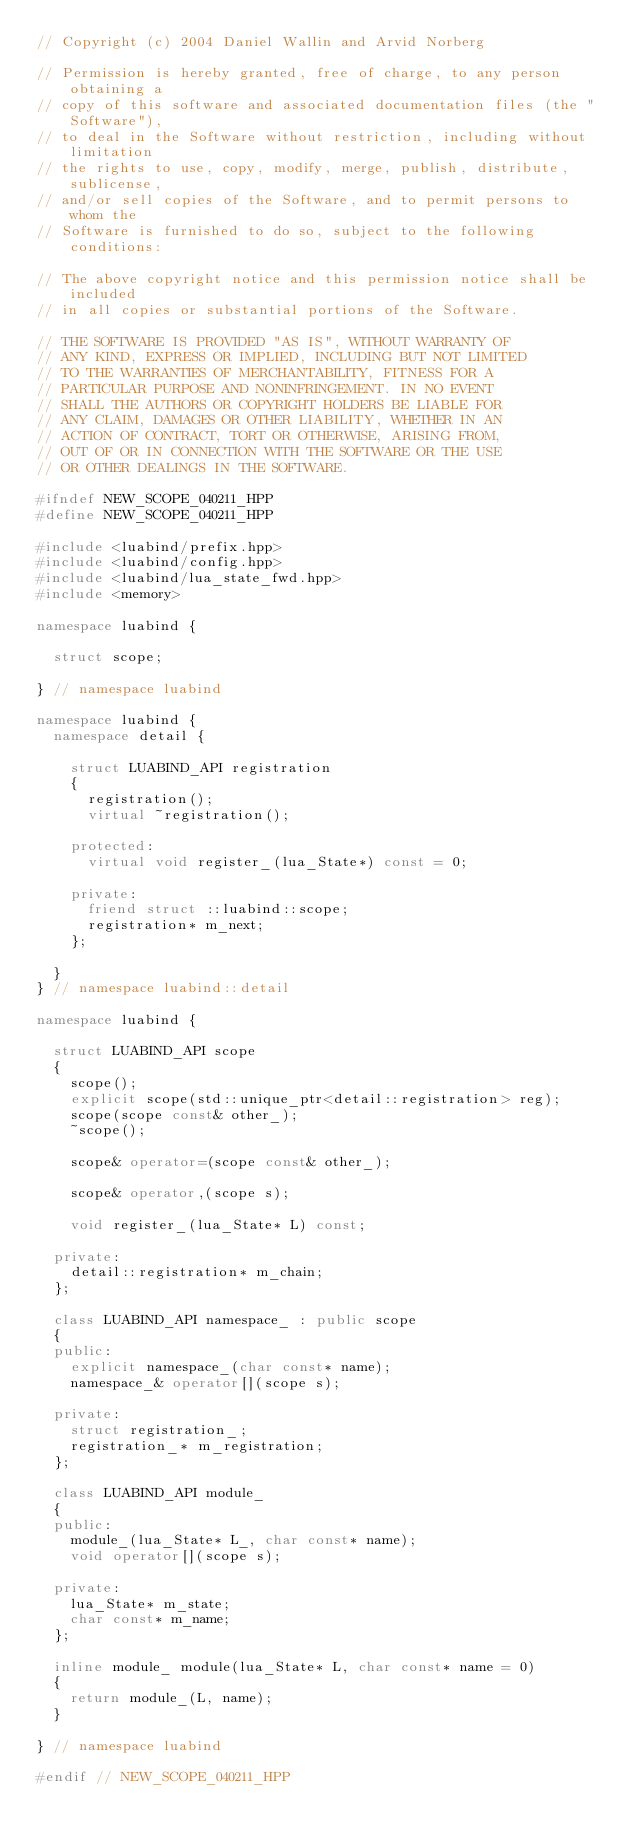<code> <loc_0><loc_0><loc_500><loc_500><_C++_>// Copyright (c) 2004 Daniel Wallin and Arvid Norberg

// Permission is hereby granted, free of charge, to any person obtaining a
// copy of this software and associated documentation files (the "Software"),
// to deal in the Software without restriction, including without limitation
// the rights to use, copy, modify, merge, publish, distribute, sublicense,
// and/or sell copies of the Software, and to permit persons to whom the
// Software is furnished to do so, subject to the following conditions:

// The above copyright notice and this permission notice shall be included
// in all copies or substantial portions of the Software.

// THE SOFTWARE IS PROVIDED "AS IS", WITHOUT WARRANTY OF
// ANY KIND, EXPRESS OR IMPLIED, INCLUDING BUT NOT LIMITED
// TO THE WARRANTIES OF MERCHANTABILITY, FITNESS FOR A
// PARTICULAR PURPOSE AND NONINFRINGEMENT. IN NO EVENT
// SHALL THE AUTHORS OR COPYRIGHT HOLDERS BE LIABLE FOR
// ANY CLAIM, DAMAGES OR OTHER LIABILITY, WHETHER IN AN
// ACTION OF CONTRACT, TORT OR OTHERWISE, ARISING FROM,
// OUT OF OR IN CONNECTION WITH THE SOFTWARE OR THE USE
// OR OTHER DEALINGS IN THE SOFTWARE.

#ifndef NEW_SCOPE_040211_HPP
#define NEW_SCOPE_040211_HPP

#include <luabind/prefix.hpp>
#include <luabind/config.hpp>
#include <luabind/lua_state_fwd.hpp>
#include <memory>

namespace luabind {

	struct scope;

} // namespace luabind

namespace luabind {
	namespace detail {

		struct LUABIND_API registration
		{
			registration();
			virtual ~registration();

		protected:
			virtual void register_(lua_State*) const = 0;

		private:
			friend struct ::luabind::scope;
			registration* m_next;
		};

	}
} // namespace luabind::detail

namespace luabind {

	struct LUABIND_API scope
	{
		scope();
		explicit scope(std::unique_ptr<detail::registration> reg);
		scope(scope const& other_);
		~scope();

		scope& operator=(scope const& other_);

		scope& operator,(scope s);

		void register_(lua_State* L) const;

	private:
		detail::registration* m_chain;
	};

	class LUABIND_API namespace_ : public scope
	{
	public:
		explicit namespace_(char const* name);
		namespace_& operator[](scope s);

	private:
		struct registration_;
		registration_* m_registration;
	};

	class LUABIND_API module_
	{
	public:
		module_(lua_State* L_, char const* name);
		void operator[](scope s);

	private:
		lua_State* m_state;
		char const* m_name;
	};

	inline module_ module(lua_State* L, char const* name = 0)
	{
		return module_(L, name);
	}

} // namespace luabind

#endif // NEW_SCOPE_040211_HPP

</code> 